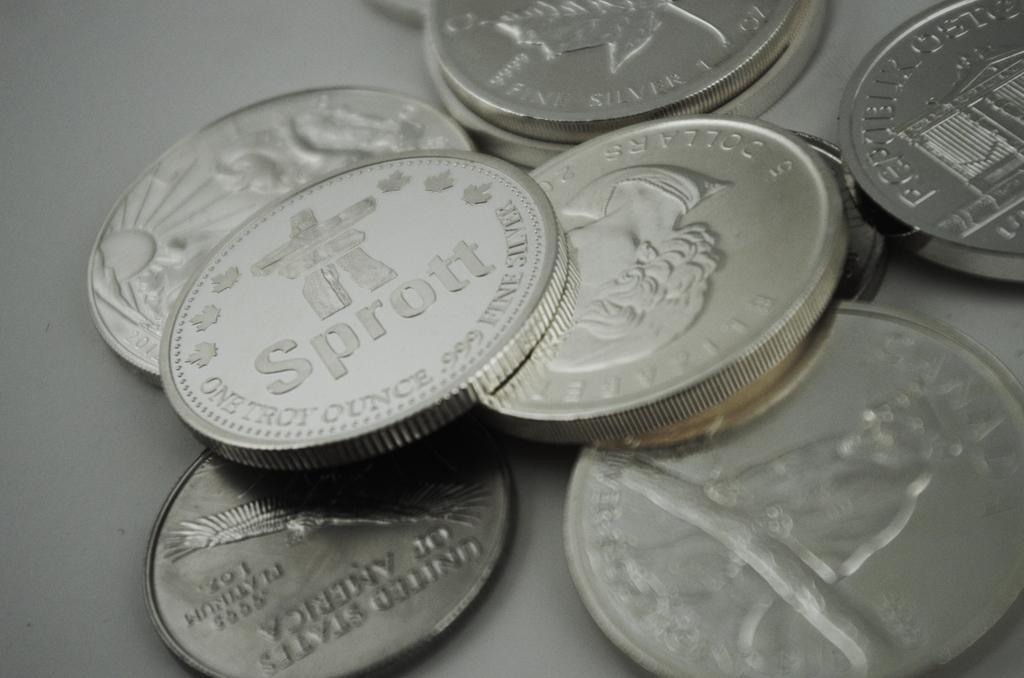Please provide a concise description of this image. In this image there is a table on that table there are coins. 